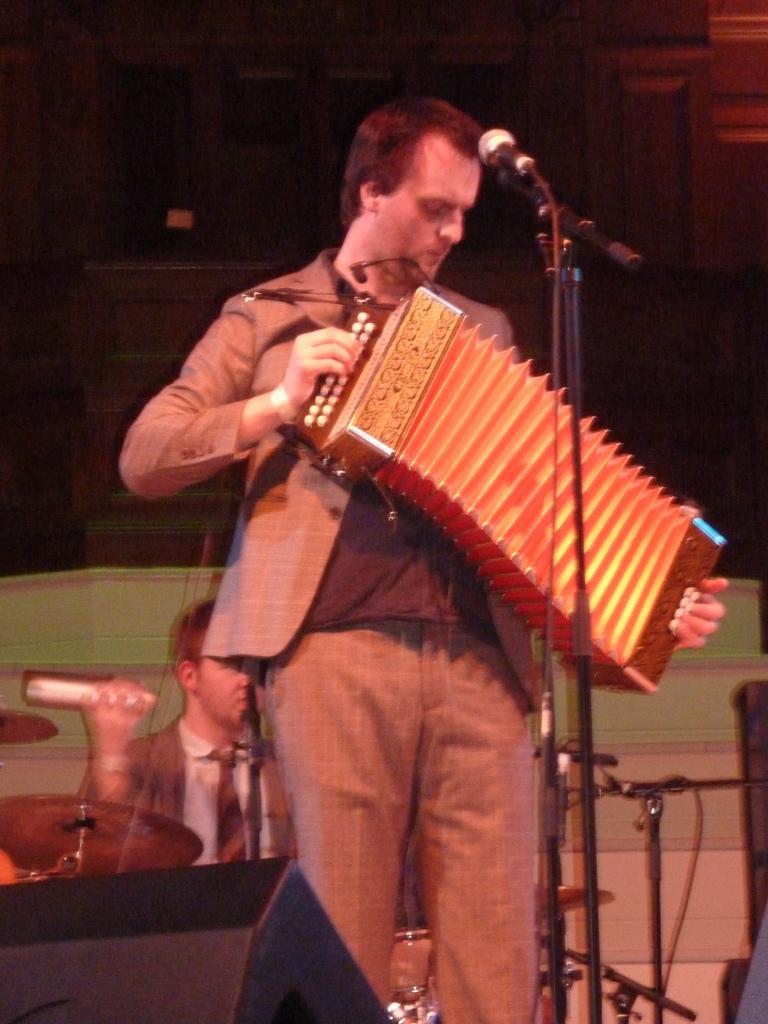Please provide a concise description of this image. In this image I can see a person is standing and holding a musical instrument in his hand. I can see a microphone in front of him and in the background I can see another person, few musical instruments and few other objects. 